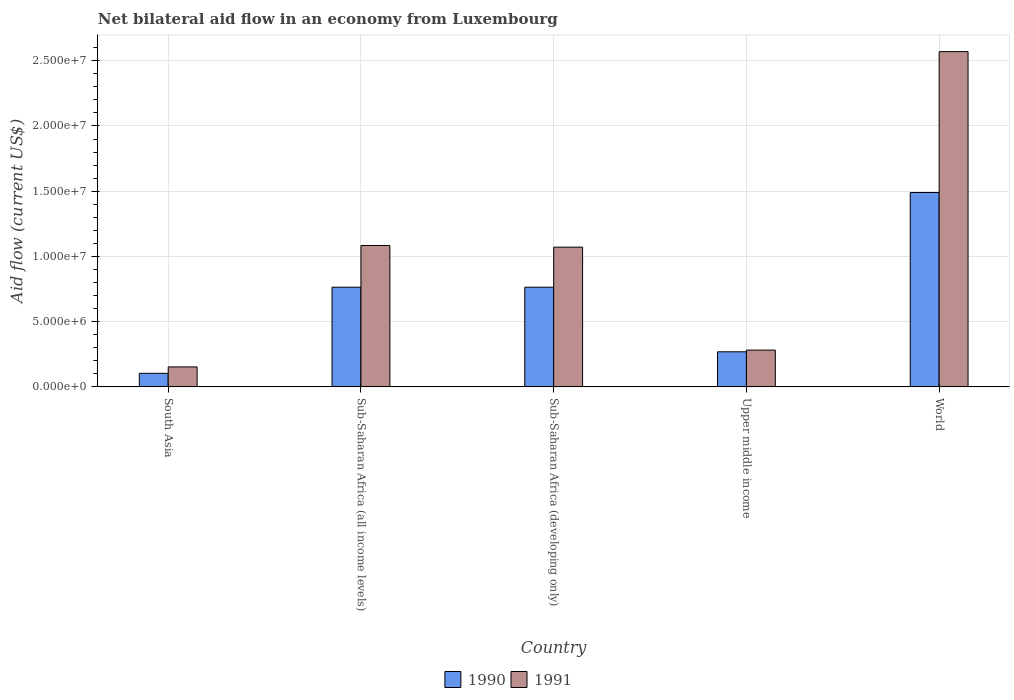How many different coloured bars are there?
Your response must be concise. 2. How many groups of bars are there?
Provide a short and direct response. 5. Are the number of bars per tick equal to the number of legend labels?
Ensure brevity in your answer.  Yes. Are the number of bars on each tick of the X-axis equal?
Provide a short and direct response. Yes. What is the label of the 3rd group of bars from the left?
Provide a short and direct response. Sub-Saharan Africa (developing only). In how many cases, is the number of bars for a given country not equal to the number of legend labels?
Keep it short and to the point. 0. What is the net bilateral aid flow in 1990 in South Asia?
Your answer should be very brief. 1.04e+06. Across all countries, what is the maximum net bilateral aid flow in 1991?
Offer a very short reply. 2.57e+07. Across all countries, what is the minimum net bilateral aid flow in 1990?
Your answer should be compact. 1.04e+06. In which country was the net bilateral aid flow in 1990 minimum?
Your answer should be very brief. South Asia. What is the total net bilateral aid flow in 1991 in the graph?
Your answer should be very brief. 5.16e+07. What is the difference between the net bilateral aid flow in 1991 in Sub-Saharan Africa (all income levels) and that in Upper middle income?
Provide a succinct answer. 8.02e+06. What is the difference between the net bilateral aid flow in 1990 in Upper middle income and the net bilateral aid flow in 1991 in World?
Offer a terse response. -2.30e+07. What is the average net bilateral aid flow in 1990 per country?
Your response must be concise. 6.78e+06. What is the ratio of the net bilateral aid flow in 1991 in Sub-Saharan Africa (all income levels) to that in Upper middle income?
Offer a terse response. 3.84. Is the net bilateral aid flow in 1990 in Sub-Saharan Africa (all income levels) less than that in World?
Make the answer very short. Yes. Is the difference between the net bilateral aid flow in 1991 in Sub-Saharan Africa (all income levels) and Upper middle income greater than the difference between the net bilateral aid flow in 1990 in Sub-Saharan Africa (all income levels) and Upper middle income?
Your answer should be very brief. Yes. What is the difference between the highest and the second highest net bilateral aid flow in 1990?
Your answer should be compact. 7.26e+06. What is the difference between the highest and the lowest net bilateral aid flow in 1990?
Keep it short and to the point. 1.39e+07. Is the sum of the net bilateral aid flow in 1990 in Sub-Saharan Africa (all income levels) and Upper middle income greater than the maximum net bilateral aid flow in 1991 across all countries?
Give a very brief answer. No. What does the 1st bar from the right in World represents?
Your response must be concise. 1991. How many bars are there?
Your answer should be compact. 10. How many countries are there in the graph?
Your answer should be compact. 5. What is the difference between two consecutive major ticks on the Y-axis?
Offer a very short reply. 5.00e+06. Are the values on the major ticks of Y-axis written in scientific E-notation?
Provide a succinct answer. Yes. Does the graph contain any zero values?
Your answer should be compact. No. How many legend labels are there?
Your answer should be compact. 2. How are the legend labels stacked?
Your answer should be very brief. Horizontal. What is the title of the graph?
Your answer should be very brief. Net bilateral aid flow in an economy from Luxembourg. What is the label or title of the X-axis?
Make the answer very short. Country. What is the Aid flow (current US$) of 1990 in South Asia?
Offer a very short reply. 1.04e+06. What is the Aid flow (current US$) in 1991 in South Asia?
Ensure brevity in your answer.  1.53e+06. What is the Aid flow (current US$) of 1990 in Sub-Saharan Africa (all income levels)?
Your response must be concise. 7.64e+06. What is the Aid flow (current US$) in 1991 in Sub-Saharan Africa (all income levels)?
Give a very brief answer. 1.08e+07. What is the Aid flow (current US$) of 1990 in Sub-Saharan Africa (developing only)?
Give a very brief answer. 7.64e+06. What is the Aid flow (current US$) of 1991 in Sub-Saharan Africa (developing only)?
Offer a very short reply. 1.07e+07. What is the Aid flow (current US$) of 1990 in Upper middle income?
Keep it short and to the point. 2.69e+06. What is the Aid flow (current US$) of 1991 in Upper middle income?
Provide a short and direct response. 2.82e+06. What is the Aid flow (current US$) in 1990 in World?
Provide a short and direct response. 1.49e+07. What is the Aid flow (current US$) of 1991 in World?
Provide a succinct answer. 2.57e+07. Across all countries, what is the maximum Aid flow (current US$) in 1990?
Ensure brevity in your answer.  1.49e+07. Across all countries, what is the maximum Aid flow (current US$) of 1991?
Give a very brief answer. 2.57e+07. Across all countries, what is the minimum Aid flow (current US$) in 1990?
Make the answer very short. 1.04e+06. Across all countries, what is the minimum Aid flow (current US$) of 1991?
Your answer should be very brief. 1.53e+06. What is the total Aid flow (current US$) of 1990 in the graph?
Ensure brevity in your answer.  3.39e+07. What is the total Aid flow (current US$) of 1991 in the graph?
Make the answer very short. 5.16e+07. What is the difference between the Aid flow (current US$) in 1990 in South Asia and that in Sub-Saharan Africa (all income levels)?
Keep it short and to the point. -6.60e+06. What is the difference between the Aid flow (current US$) in 1991 in South Asia and that in Sub-Saharan Africa (all income levels)?
Your answer should be very brief. -9.31e+06. What is the difference between the Aid flow (current US$) in 1990 in South Asia and that in Sub-Saharan Africa (developing only)?
Ensure brevity in your answer.  -6.60e+06. What is the difference between the Aid flow (current US$) of 1991 in South Asia and that in Sub-Saharan Africa (developing only)?
Your answer should be compact. -9.18e+06. What is the difference between the Aid flow (current US$) of 1990 in South Asia and that in Upper middle income?
Offer a terse response. -1.65e+06. What is the difference between the Aid flow (current US$) in 1991 in South Asia and that in Upper middle income?
Your answer should be very brief. -1.29e+06. What is the difference between the Aid flow (current US$) of 1990 in South Asia and that in World?
Your answer should be compact. -1.39e+07. What is the difference between the Aid flow (current US$) in 1991 in South Asia and that in World?
Your answer should be compact. -2.42e+07. What is the difference between the Aid flow (current US$) in 1990 in Sub-Saharan Africa (all income levels) and that in Upper middle income?
Ensure brevity in your answer.  4.95e+06. What is the difference between the Aid flow (current US$) in 1991 in Sub-Saharan Africa (all income levels) and that in Upper middle income?
Provide a succinct answer. 8.02e+06. What is the difference between the Aid flow (current US$) in 1990 in Sub-Saharan Africa (all income levels) and that in World?
Ensure brevity in your answer.  -7.26e+06. What is the difference between the Aid flow (current US$) of 1991 in Sub-Saharan Africa (all income levels) and that in World?
Your answer should be very brief. -1.49e+07. What is the difference between the Aid flow (current US$) in 1990 in Sub-Saharan Africa (developing only) and that in Upper middle income?
Your answer should be very brief. 4.95e+06. What is the difference between the Aid flow (current US$) of 1991 in Sub-Saharan Africa (developing only) and that in Upper middle income?
Your response must be concise. 7.89e+06. What is the difference between the Aid flow (current US$) in 1990 in Sub-Saharan Africa (developing only) and that in World?
Provide a succinct answer. -7.26e+06. What is the difference between the Aid flow (current US$) of 1991 in Sub-Saharan Africa (developing only) and that in World?
Keep it short and to the point. -1.50e+07. What is the difference between the Aid flow (current US$) in 1990 in Upper middle income and that in World?
Offer a very short reply. -1.22e+07. What is the difference between the Aid flow (current US$) in 1991 in Upper middle income and that in World?
Offer a very short reply. -2.29e+07. What is the difference between the Aid flow (current US$) of 1990 in South Asia and the Aid flow (current US$) of 1991 in Sub-Saharan Africa (all income levels)?
Provide a succinct answer. -9.80e+06. What is the difference between the Aid flow (current US$) of 1990 in South Asia and the Aid flow (current US$) of 1991 in Sub-Saharan Africa (developing only)?
Make the answer very short. -9.67e+06. What is the difference between the Aid flow (current US$) in 1990 in South Asia and the Aid flow (current US$) in 1991 in Upper middle income?
Ensure brevity in your answer.  -1.78e+06. What is the difference between the Aid flow (current US$) in 1990 in South Asia and the Aid flow (current US$) in 1991 in World?
Offer a terse response. -2.47e+07. What is the difference between the Aid flow (current US$) of 1990 in Sub-Saharan Africa (all income levels) and the Aid flow (current US$) of 1991 in Sub-Saharan Africa (developing only)?
Provide a succinct answer. -3.07e+06. What is the difference between the Aid flow (current US$) of 1990 in Sub-Saharan Africa (all income levels) and the Aid flow (current US$) of 1991 in Upper middle income?
Offer a terse response. 4.82e+06. What is the difference between the Aid flow (current US$) of 1990 in Sub-Saharan Africa (all income levels) and the Aid flow (current US$) of 1991 in World?
Offer a very short reply. -1.81e+07. What is the difference between the Aid flow (current US$) of 1990 in Sub-Saharan Africa (developing only) and the Aid flow (current US$) of 1991 in Upper middle income?
Offer a very short reply. 4.82e+06. What is the difference between the Aid flow (current US$) in 1990 in Sub-Saharan Africa (developing only) and the Aid flow (current US$) in 1991 in World?
Make the answer very short. -1.81e+07. What is the difference between the Aid flow (current US$) of 1990 in Upper middle income and the Aid flow (current US$) of 1991 in World?
Keep it short and to the point. -2.30e+07. What is the average Aid flow (current US$) in 1990 per country?
Provide a succinct answer. 6.78e+06. What is the average Aid flow (current US$) in 1991 per country?
Give a very brief answer. 1.03e+07. What is the difference between the Aid flow (current US$) of 1990 and Aid flow (current US$) of 1991 in South Asia?
Your answer should be compact. -4.90e+05. What is the difference between the Aid flow (current US$) of 1990 and Aid flow (current US$) of 1991 in Sub-Saharan Africa (all income levels)?
Your answer should be compact. -3.20e+06. What is the difference between the Aid flow (current US$) in 1990 and Aid flow (current US$) in 1991 in Sub-Saharan Africa (developing only)?
Offer a very short reply. -3.07e+06. What is the difference between the Aid flow (current US$) of 1990 and Aid flow (current US$) of 1991 in Upper middle income?
Offer a terse response. -1.30e+05. What is the difference between the Aid flow (current US$) of 1990 and Aid flow (current US$) of 1991 in World?
Keep it short and to the point. -1.08e+07. What is the ratio of the Aid flow (current US$) in 1990 in South Asia to that in Sub-Saharan Africa (all income levels)?
Your response must be concise. 0.14. What is the ratio of the Aid flow (current US$) of 1991 in South Asia to that in Sub-Saharan Africa (all income levels)?
Keep it short and to the point. 0.14. What is the ratio of the Aid flow (current US$) in 1990 in South Asia to that in Sub-Saharan Africa (developing only)?
Make the answer very short. 0.14. What is the ratio of the Aid flow (current US$) of 1991 in South Asia to that in Sub-Saharan Africa (developing only)?
Offer a terse response. 0.14. What is the ratio of the Aid flow (current US$) of 1990 in South Asia to that in Upper middle income?
Keep it short and to the point. 0.39. What is the ratio of the Aid flow (current US$) in 1991 in South Asia to that in Upper middle income?
Your answer should be compact. 0.54. What is the ratio of the Aid flow (current US$) in 1990 in South Asia to that in World?
Your answer should be compact. 0.07. What is the ratio of the Aid flow (current US$) in 1991 in South Asia to that in World?
Provide a succinct answer. 0.06. What is the ratio of the Aid flow (current US$) in 1991 in Sub-Saharan Africa (all income levels) to that in Sub-Saharan Africa (developing only)?
Keep it short and to the point. 1.01. What is the ratio of the Aid flow (current US$) of 1990 in Sub-Saharan Africa (all income levels) to that in Upper middle income?
Your response must be concise. 2.84. What is the ratio of the Aid flow (current US$) in 1991 in Sub-Saharan Africa (all income levels) to that in Upper middle income?
Provide a short and direct response. 3.84. What is the ratio of the Aid flow (current US$) of 1990 in Sub-Saharan Africa (all income levels) to that in World?
Make the answer very short. 0.51. What is the ratio of the Aid flow (current US$) in 1991 in Sub-Saharan Africa (all income levels) to that in World?
Your answer should be very brief. 0.42. What is the ratio of the Aid flow (current US$) of 1990 in Sub-Saharan Africa (developing only) to that in Upper middle income?
Your answer should be compact. 2.84. What is the ratio of the Aid flow (current US$) in 1991 in Sub-Saharan Africa (developing only) to that in Upper middle income?
Your answer should be compact. 3.8. What is the ratio of the Aid flow (current US$) in 1990 in Sub-Saharan Africa (developing only) to that in World?
Your answer should be compact. 0.51. What is the ratio of the Aid flow (current US$) in 1991 in Sub-Saharan Africa (developing only) to that in World?
Make the answer very short. 0.42. What is the ratio of the Aid flow (current US$) in 1990 in Upper middle income to that in World?
Your response must be concise. 0.18. What is the ratio of the Aid flow (current US$) of 1991 in Upper middle income to that in World?
Offer a terse response. 0.11. What is the difference between the highest and the second highest Aid flow (current US$) in 1990?
Make the answer very short. 7.26e+06. What is the difference between the highest and the second highest Aid flow (current US$) of 1991?
Offer a terse response. 1.49e+07. What is the difference between the highest and the lowest Aid flow (current US$) in 1990?
Your answer should be compact. 1.39e+07. What is the difference between the highest and the lowest Aid flow (current US$) in 1991?
Offer a terse response. 2.42e+07. 